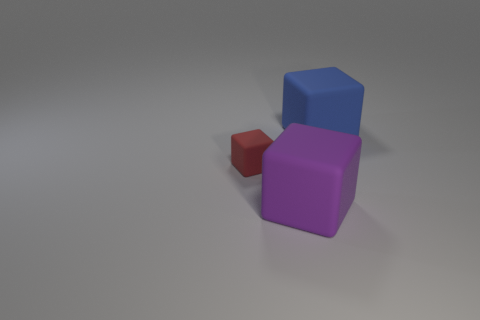What number of tiny objects are the same shape as the big blue rubber thing?
Give a very brief answer. 1. What is the large object that is on the left side of the big rubber object behind the large purple rubber block made of?
Make the answer very short. Rubber. Are there any tiny objects that have the same material as the tiny block?
Ensure brevity in your answer.  No. How many big cyan objects are there?
Keep it short and to the point. 0. What color is the large thing in front of the rubber thing to the left of the purple rubber cube?
Offer a very short reply. Purple. There is a matte cube that is the same size as the blue matte object; what color is it?
Your answer should be compact. Purple. Is there a small metal ball that has the same color as the small thing?
Keep it short and to the point. No. Is there a big blue matte object?
Your answer should be very brief. Yes. There is a big object behind the small red rubber object; what shape is it?
Provide a short and direct response. Cube. What number of cubes are both to the left of the big purple rubber object and on the right side of the big purple object?
Provide a short and direct response. 0. 